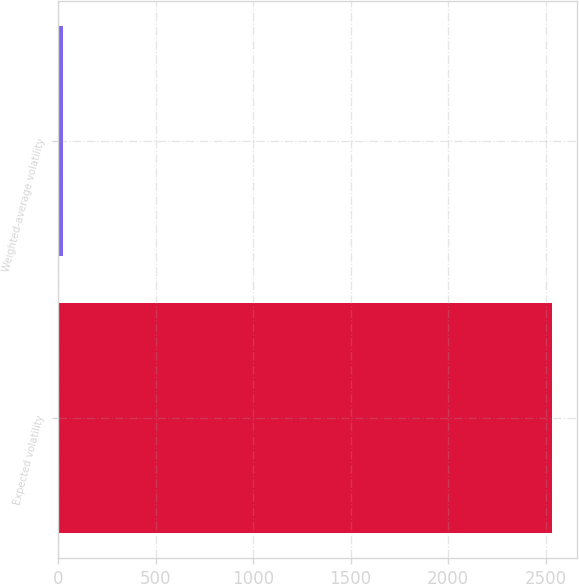Convert chart to OTSL. <chart><loc_0><loc_0><loc_500><loc_500><bar_chart><fcel>Expected volatility<fcel>Weighted-average volatility<nl><fcel>2532<fcel>27<nl></chart> 